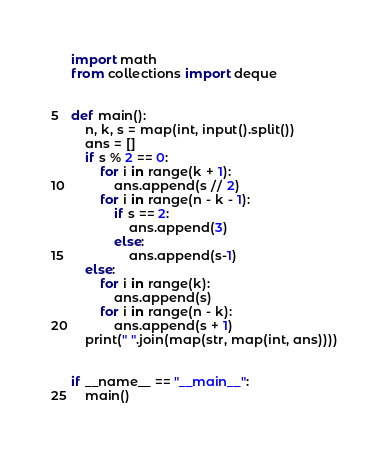Convert code to text. <code><loc_0><loc_0><loc_500><loc_500><_Python_>import math
from collections import deque


def main():
    n, k, s = map(int, input().split())
    ans = []
    if s % 2 == 0:
        for i in range(k + 1):
            ans.append(s // 2)
        for i in range(n - k - 1):
            if s == 2:
                ans.append(3)
            else:
                ans.append(s-1)
    else:
        for i in range(k):
            ans.append(s)
        for i in range(n - k):
            ans.append(s + 1)
    print(" ".join(map(str, map(int, ans))))


if __name__ == "__main__":
    main()
</code> 